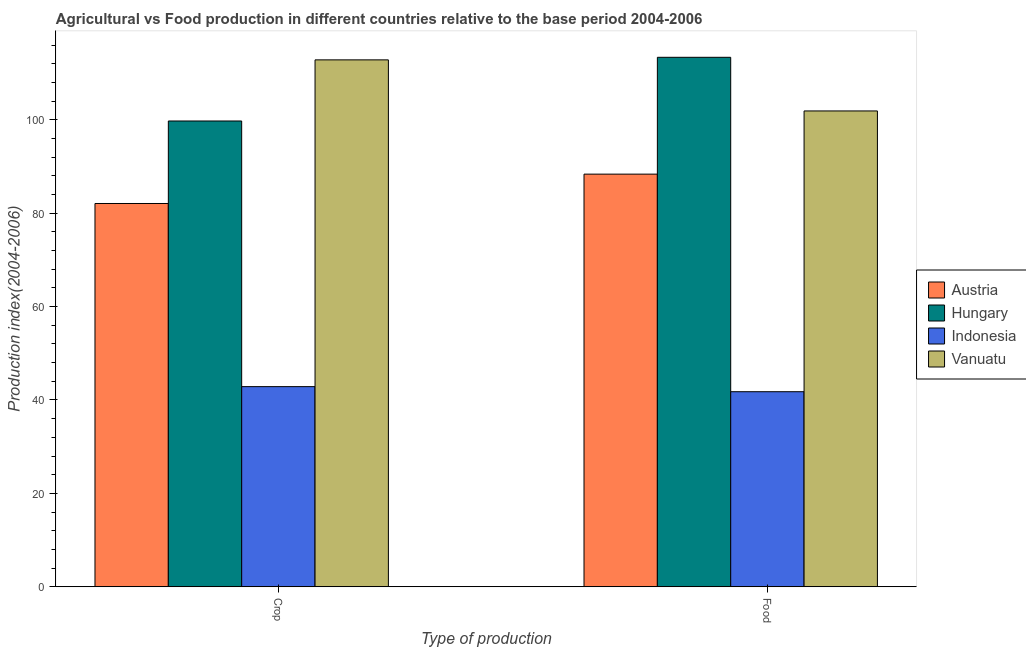How many different coloured bars are there?
Offer a very short reply. 4. How many groups of bars are there?
Give a very brief answer. 2. Are the number of bars on each tick of the X-axis equal?
Ensure brevity in your answer.  Yes. How many bars are there on the 1st tick from the right?
Offer a terse response. 4. What is the label of the 2nd group of bars from the left?
Provide a succinct answer. Food. What is the food production index in Indonesia?
Ensure brevity in your answer.  41.77. Across all countries, what is the maximum food production index?
Provide a short and direct response. 113.39. Across all countries, what is the minimum food production index?
Your response must be concise. 41.77. In which country was the food production index maximum?
Provide a short and direct response. Hungary. What is the total food production index in the graph?
Provide a succinct answer. 345.43. What is the difference between the crop production index in Austria and that in Indonesia?
Make the answer very short. 39.22. What is the difference between the crop production index in Indonesia and the food production index in Vanuatu?
Offer a very short reply. -59.04. What is the average food production index per country?
Make the answer very short. 86.36. What is the difference between the food production index and crop production index in Vanuatu?
Provide a succinct answer. -10.94. In how many countries, is the food production index greater than 96 ?
Offer a terse response. 2. What is the ratio of the crop production index in Austria to that in Vanuatu?
Your answer should be very brief. 0.73. In how many countries, is the food production index greater than the average food production index taken over all countries?
Provide a succinct answer. 3. What does the 1st bar from the right in Food represents?
Keep it short and to the point. Vanuatu. How many bars are there?
Offer a terse response. 8. Are all the bars in the graph horizontal?
Give a very brief answer. No. How many countries are there in the graph?
Your answer should be compact. 4. What is the difference between two consecutive major ticks on the Y-axis?
Give a very brief answer. 20. Are the values on the major ticks of Y-axis written in scientific E-notation?
Your answer should be compact. No. Does the graph contain any zero values?
Give a very brief answer. No. Does the graph contain grids?
Offer a terse response. No. How are the legend labels stacked?
Keep it short and to the point. Vertical. What is the title of the graph?
Make the answer very short. Agricultural vs Food production in different countries relative to the base period 2004-2006. Does "Congo (Republic)" appear as one of the legend labels in the graph?
Offer a terse response. No. What is the label or title of the X-axis?
Provide a succinct answer. Type of production. What is the label or title of the Y-axis?
Your answer should be compact. Production index(2004-2006). What is the Production index(2004-2006) of Austria in Crop?
Provide a succinct answer. 82.08. What is the Production index(2004-2006) in Hungary in Crop?
Your answer should be compact. 99.75. What is the Production index(2004-2006) in Indonesia in Crop?
Your answer should be compact. 42.86. What is the Production index(2004-2006) in Vanuatu in Crop?
Your response must be concise. 112.84. What is the Production index(2004-2006) in Austria in Food?
Your answer should be compact. 88.37. What is the Production index(2004-2006) of Hungary in Food?
Provide a short and direct response. 113.39. What is the Production index(2004-2006) of Indonesia in Food?
Your response must be concise. 41.77. What is the Production index(2004-2006) in Vanuatu in Food?
Make the answer very short. 101.9. Across all Type of production, what is the maximum Production index(2004-2006) of Austria?
Offer a very short reply. 88.37. Across all Type of production, what is the maximum Production index(2004-2006) in Hungary?
Ensure brevity in your answer.  113.39. Across all Type of production, what is the maximum Production index(2004-2006) of Indonesia?
Ensure brevity in your answer.  42.86. Across all Type of production, what is the maximum Production index(2004-2006) in Vanuatu?
Ensure brevity in your answer.  112.84. Across all Type of production, what is the minimum Production index(2004-2006) in Austria?
Keep it short and to the point. 82.08. Across all Type of production, what is the minimum Production index(2004-2006) of Hungary?
Your response must be concise. 99.75. Across all Type of production, what is the minimum Production index(2004-2006) in Indonesia?
Keep it short and to the point. 41.77. Across all Type of production, what is the minimum Production index(2004-2006) of Vanuatu?
Provide a succinct answer. 101.9. What is the total Production index(2004-2006) in Austria in the graph?
Offer a terse response. 170.45. What is the total Production index(2004-2006) in Hungary in the graph?
Your answer should be very brief. 213.14. What is the total Production index(2004-2006) in Indonesia in the graph?
Your response must be concise. 84.63. What is the total Production index(2004-2006) of Vanuatu in the graph?
Offer a very short reply. 214.74. What is the difference between the Production index(2004-2006) of Austria in Crop and that in Food?
Give a very brief answer. -6.29. What is the difference between the Production index(2004-2006) of Hungary in Crop and that in Food?
Provide a succinct answer. -13.64. What is the difference between the Production index(2004-2006) in Indonesia in Crop and that in Food?
Your answer should be compact. 1.09. What is the difference between the Production index(2004-2006) in Vanuatu in Crop and that in Food?
Your answer should be very brief. 10.94. What is the difference between the Production index(2004-2006) in Austria in Crop and the Production index(2004-2006) in Hungary in Food?
Your answer should be very brief. -31.31. What is the difference between the Production index(2004-2006) of Austria in Crop and the Production index(2004-2006) of Indonesia in Food?
Provide a short and direct response. 40.31. What is the difference between the Production index(2004-2006) of Austria in Crop and the Production index(2004-2006) of Vanuatu in Food?
Ensure brevity in your answer.  -19.82. What is the difference between the Production index(2004-2006) of Hungary in Crop and the Production index(2004-2006) of Indonesia in Food?
Ensure brevity in your answer.  57.98. What is the difference between the Production index(2004-2006) in Hungary in Crop and the Production index(2004-2006) in Vanuatu in Food?
Offer a very short reply. -2.15. What is the difference between the Production index(2004-2006) in Indonesia in Crop and the Production index(2004-2006) in Vanuatu in Food?
Your response must be concise. -59.04. What is the average Production index(2004-2006) in Austria per Type of production?
Your answer should be very brief. 85.22. What is the average Production index(2004-2006) of Hungary per Type of production?
Make the answer very short. 106.57. What is the average Production index(2004-2006) of Indonesia per Type of production?
Provide a short and direct response. 42.31. What is the average Production index(2004-2006) of Vanuatu per Type of production?
Make the answer very short. 107.37. What is the difference between the Production index(2004-2006) in Austria and Production index(2004-2006) in Hungary in Crop?
Keep it short and to the point. -17.67. What is the difference between the Production index(2004-2006) of Austria and Production index(2004-2006) of Indonesia in Crop?
Offer a terse response. 39.22. What is the difference between the Production index(2004-2006) in Austria and Production index(2004-2006) in Vanuatu in Crop?
Provide a short and direct response. -30.76. What is the difference between the Production index(2004-2006) of Hungary and Production index(2004-2006) of Indonesia in Crop?
Offer a terse response. 56.89. What is the difference between the Production index(2004-2006) of Hungary and Production index(2004-2006) of Vanuatu in Crop?
Make the answer very short. -13.09. What is the difference between the Production index(2004-2006) in Indonesia and Production index(2004-2006) in Vanuatu in Crop?
Keep it short and to the point. -69.98. What is the difference between the Production index(2004-2006) in Austria and Production index(2004-2006) in Hungary in Food?
Your response must be concise. -25.02. What is the difference between the Production index(2004-2006) of Austria and Production index(2004-2006) of Indonesia in Food?
Offer a terse response. 46.6. What is the difference between the Production index(2004-2006) of Austria and Production index(2004-2006) of Vanuatu in Food?
Offer a terse response. -13.53. What is the difference between the Production index(2004-2006) of Hungary and Production index(2004-2006) of Indonesia in Food?
Make the answer very short. 71.62. What is the difference between the Production index(2004-2006) of Hungary and Production index(2004-2006) of Vanuatu in Food?
Offer a very short reply. 11.49. What is the difference between the Production index(2004-2006) of Indonesia and Production index(2004-2006) of Vanuatu in Food?
Keep it short and to the point. -60.13. What is the ratio of the Production index(2004-2006) of Austria in Crop to that in Food?
Keep it short and to the point. 0.93. What is the ratio of the Production index(2004-2006) in Hungary in Crop to that in Food?
Make the answer very short. 0.88. What is the ratio of the Production index(2004-2006) of Indonesia in Crop to that in Food?
Provide a short and direct response. 1.03. What is the ratio of the Production index(2004-2006) in Vanuatu in Crop to that in Food?
Provide a short and direct response. 1.11. What is the difference between the highest and the second highest Production index(2004-2006) of Austria?
Keep it short and to the point. 6.29. What is the difference between the highest and the second highest Production index(2004-2006) of Hungary?
Keep it short and to the point. 13.64. What is the difference between the highest and the second highest Production index(2004-2006) in Indonesia?
Ensure brevity in your answer.  1.09. What is the difference between the highest and the second highest Production index(2004-2006) in Vanuatu?
Ensure brevity in your answer.  10.94. What is the difference between the highest and the lowest Production index(2004-2006) of Austria?
Ensure brevity in your answer.  6.29. What is the difference between the highest and the lowest Production index(2004-2006) in Hungary?
Provide a succinct answer. 13.64. What is the difference between the highest and the lowest Production index(2004-2006) of Indonesia?
Give a very brief answer. 1.09. What is the difference between the highest and the lowest Production index(2004-2006) of Vanuatu?
Offer a terse response. 10.94. 